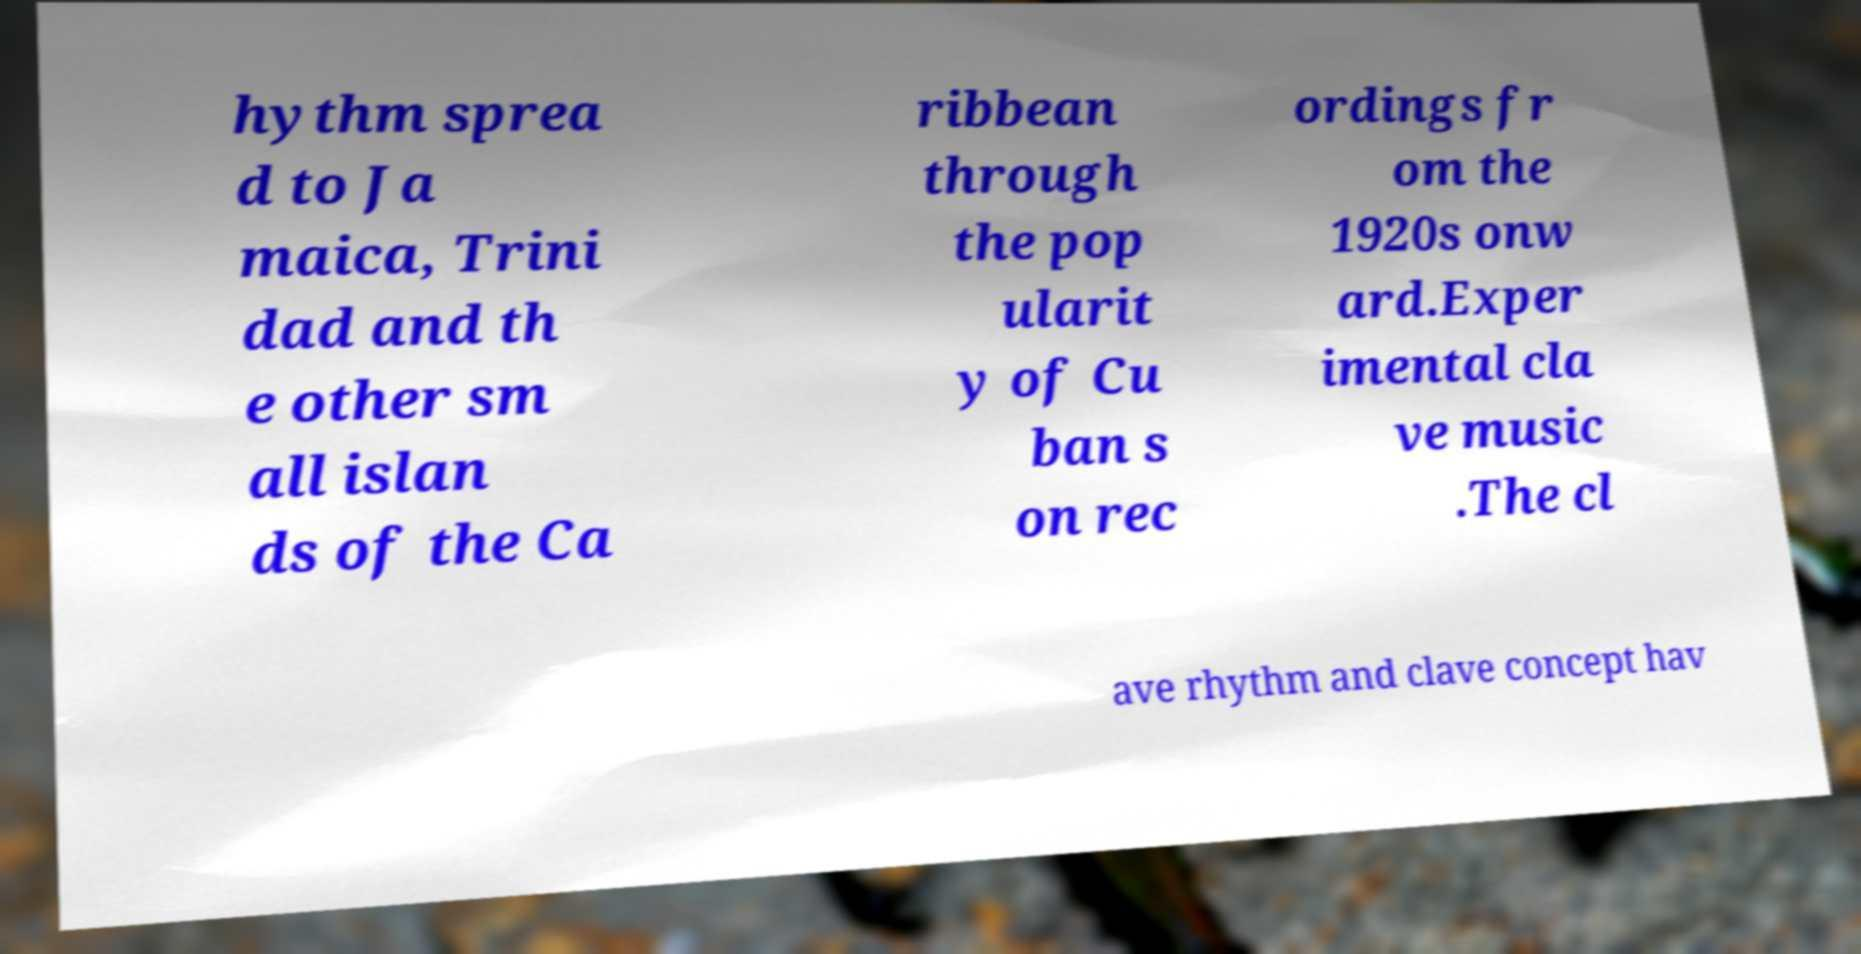Can you read and provide the text displayed in the image?This photo seems to have some interesting text. Can you extract and type it out for me? hythm sprea d to Ja maica, Trini dad and th e other sm all islan ds of the Ca ribbean through the pop ularit y of Cu ban s on rec ordings fr om the 1920s onw ard.Exper imental cla ve music .The cl ave rhythm and clave concept hav 